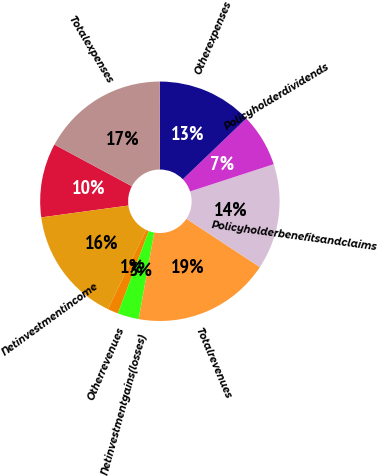Convert chart. <chart><loc_0><loc_0><loc_500><loc_500><pie_chart><ecel><fcel>Netinvestmentincome<fcel>Otherrevenues<fcel>Netinvestmentgains(losses)<fcel>Totalrevenues<fcel>Policyholderbenefitsandclaims<fcel>Policyholderdividends<fcel>Otherexpenses<fcel>Totalexpenses<nl><fcel>10.0%<fcel>15.71%<fcel>1.44%<fcel>2.87%<fcel>18.56%<fcel>14.28%<fcel>7.15%<fcel>12.85%<fcel>17.13%<nl></chart> 